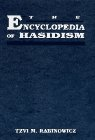Can you tell me more about the author of this book? The author, Tzvi M. Rabinowicz, is a scholar renowned for his extensive research and writings on Jewish theology, particularly within the Hasidic tradition. He has contributed significantly to understanding and documenting the rich heritage of Hasidism. 